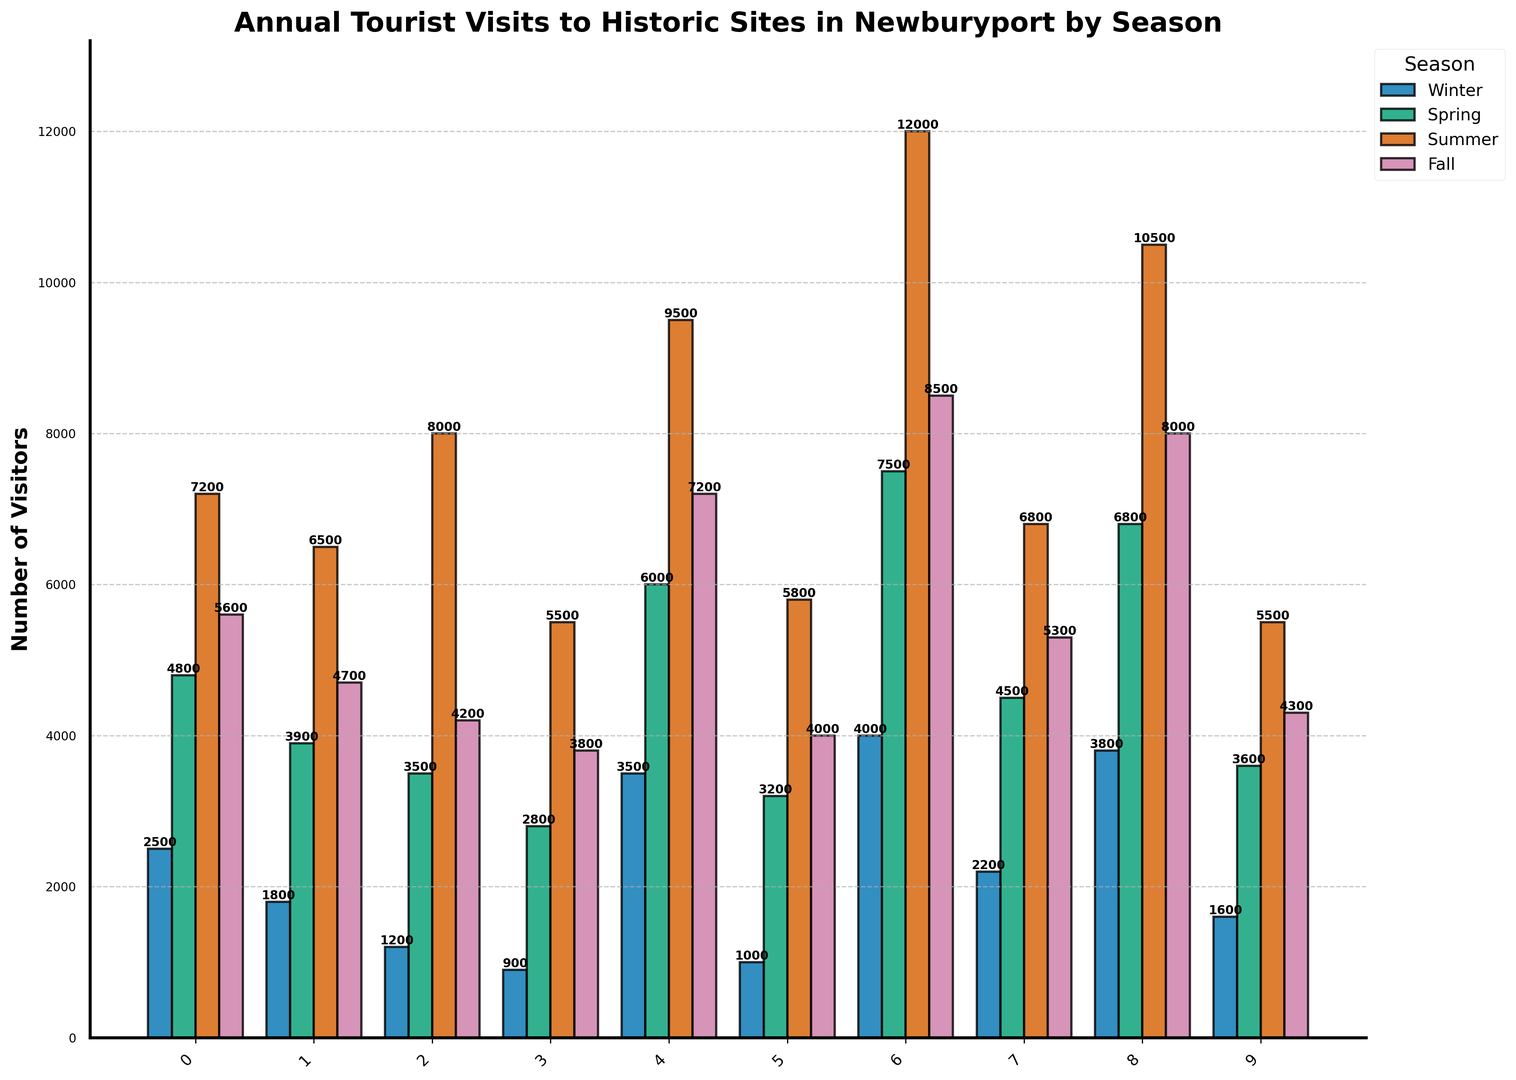Which site has the most visitors in Summer? Look for the tallest bar in the Summer section, which represents the highest value for Summer visitors. Compare all the bars and find that Waterfront Park has the tallest bar.
Answer: Waterfront Park How many more visitors does Maudslay State Park have in Fall compared to Winter? Subtract the number of Fall visitors from the number of Winter visitors for Maudslay State Park: 7200 (Fall) - 3500 (Winter) = 3700
Answer: 3700 Which season has the least visitors for the Newburyport Lighthouse? Look at the bars representing the Newburyport Lighthouse for each season and find the shortest one. The shortest bar corresponds to Winter.
Answer: Winter What's the difference in the number of visitors between Cushing House Museum and Spencer-Peirce-Little Farm in Spring? Subtract the number of Spring visitors at Spencer-Peirce-Little Farm from those at Cushing House Museum: 4800 (Cushing House Museum) - 3200 (Spencer-Peirce-Little Farm) = 1600
Answer: 1600 Which site has the highest number of visitors in Winter and how many? Look for the tallest bar in the Winter section and note the site it represents. Maudslay State Park has the tallest bar for Winter with 3500 visitors.
Answer: Maudslay State Park, 3500 What is the average number of visitors to Lowell's Boat Shop across all seasons? Sum the number of visitors for each season for Lowell's Boat Shop and divide by the number of seasons: (900 + 2800 + 5500 + 3800) / 4 = 3250
Answer: 3250 Compare the total yearly visitors for Joppa Flats Education Center and Custom House Maritime Museum. Which one has more? Sum the visitors for all seasons for both locations and compare: Joppa Flats Education Center: 2200 + 4500 + 6800 + 5300 = 18800; Custom House Maritime Museum: 1800 + 3900 + 6500 + 4700 = 16900. Joppa Flats Education Center has more visitors.
Answer: Joppa Flats Education Center How many total visitors did all sites combined receive in the Spring? Add the number of Spring visitors for all sites: 4800 + 3900 + 3500 + 2800 + 6000 + 3200 + 7500 + 4500 + 6800 + 3600 = 46600
Answer: 46600 